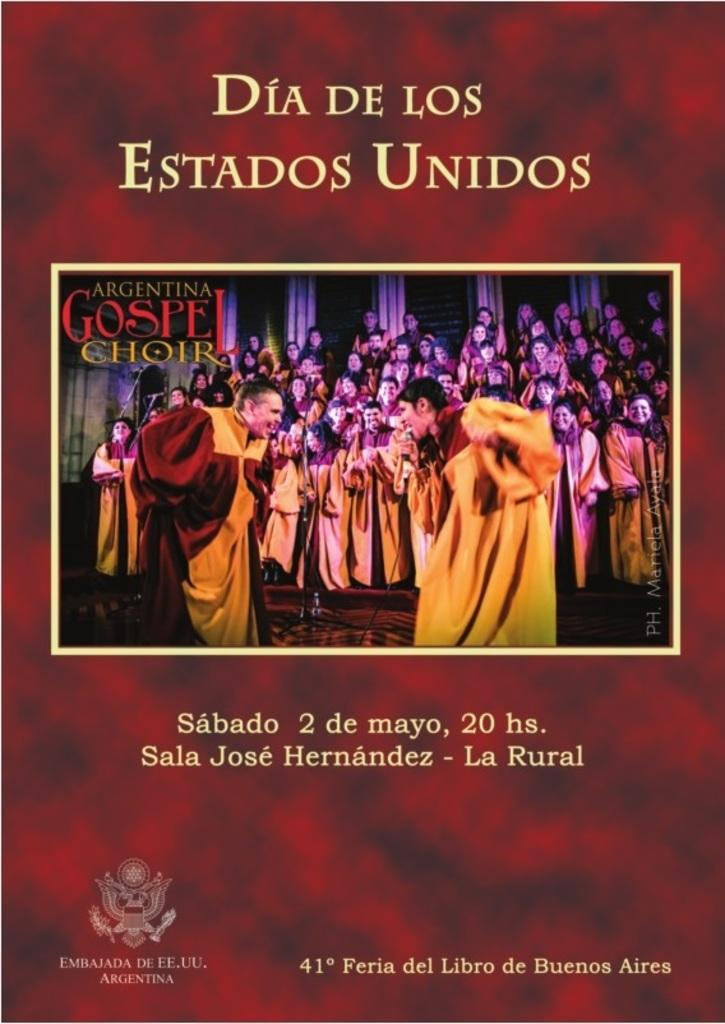What is the main object in the image? There is a flyer in the image. What is depicted on the flyer? The flyer contains a picture. What else can be found on the flyer besides the picture? The flyer contains some text. What type of lace is used to decorate the edges of the flyer? There is no lace present on the flyer; it is a printed piece of paper with a picture and text. 